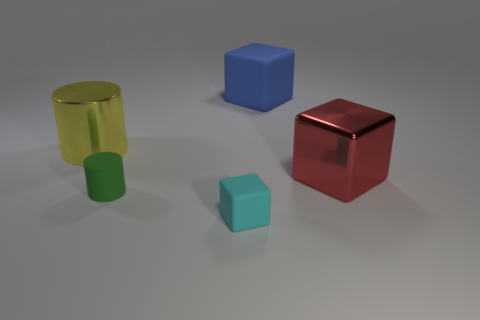Add 3 big shiny cylinders. How many objects exist? 8 Subtract all cylinders. How many objects are left? 3 Subtract all rubber cylinders. Subtract all small green objects. How many objects are left? 3 Add 3 small green rubber cylinders. How many small green rubber cylinders are left? 4 Add 5 blue things. How many blue things exist? 6 Subtract 0 green balls. How many objects are left? 5 